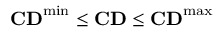<formula> <loc_0><loc_0><loc_500><loc_500>C D ^ { \min } \leq C D \leq C D ^ { \max }</formula> 